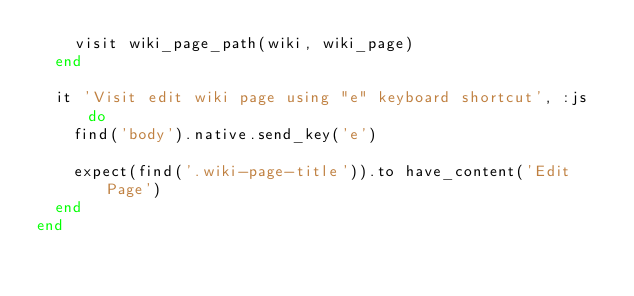Convert code to text. <code><loc_0><loc_0><loc_500><loc_500><_Ruby_>    visit wiki_page_path(wiki, wiki_page)
  end

  it 'Visit edit wiki page using "e" keyboard shortcut', :js do
    find('body').native.send_key('e')

    expect(find('.wiki-page-title')).to have_content('Edit Page')
  end
end
</code> 